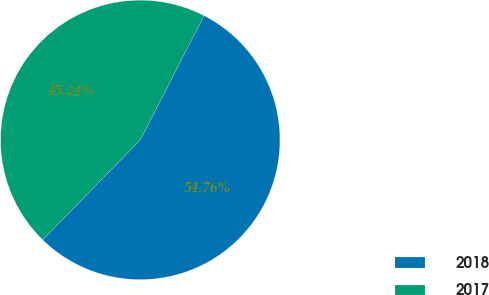Convert chart to OTSL. <chart><loc_0><loc_0><loc_500><loc_500><pie_chart><fcel>2018<fcel>2017<nl><fcel>54.76%<fcel>45.24%<nl></chart> 